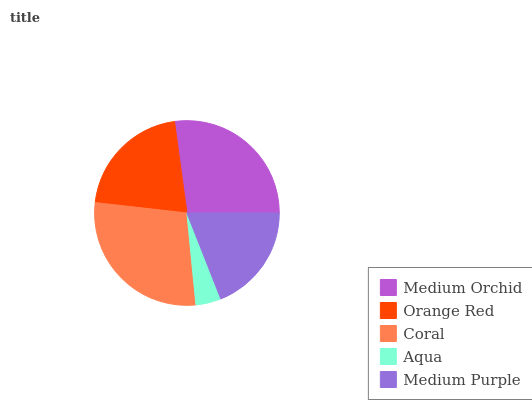Is Aqua the minimum?
Answer yes or no. Yes. Is Coral the maximum?
Answer yes or no. Yes. Is Orange Red the minimum?
Answer yes or no. No. Is Orange Red the maximum?
Answer yes or no. No. Is Medium Orchid greater than Orange Red?
Answer yes or no. Yes. Is Orange Red less than Medium Orchid?
Answer yes or no. Yes. Is Orange Red greater than Medium Orchid?
Answer yes or no. No. Is Medium Orchid less than Orange Red?
Answer yes or no. No. Is Orange Red the high median?
Answer yes or no. Yes. Is Orange Red the low median?
Answer yes or no. Yes. Is Coral the high median?
Answer yes or no. No. Is Coral the low median?
Answer yes or no. No. 